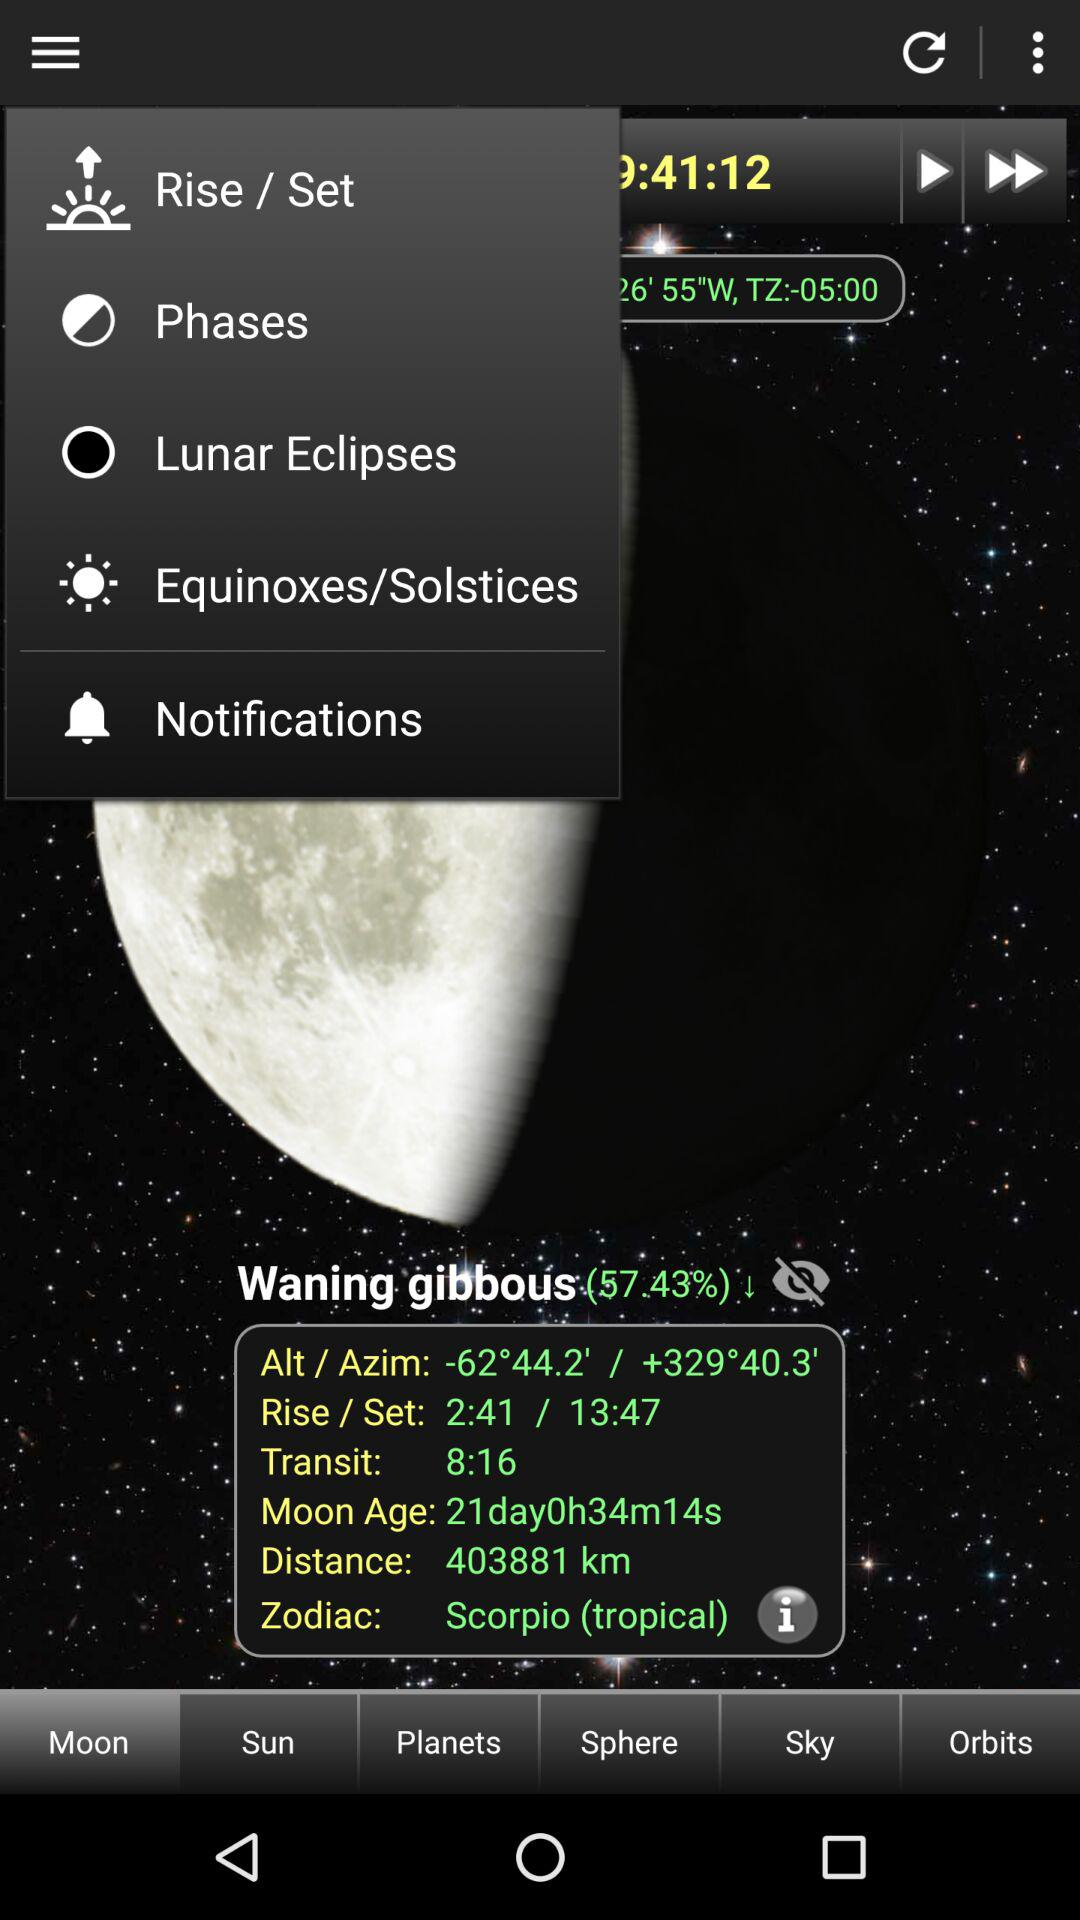What is the "Moon Age"? The moon age is 21 days, 0 hours, 34 minutes and 14 seconds. 